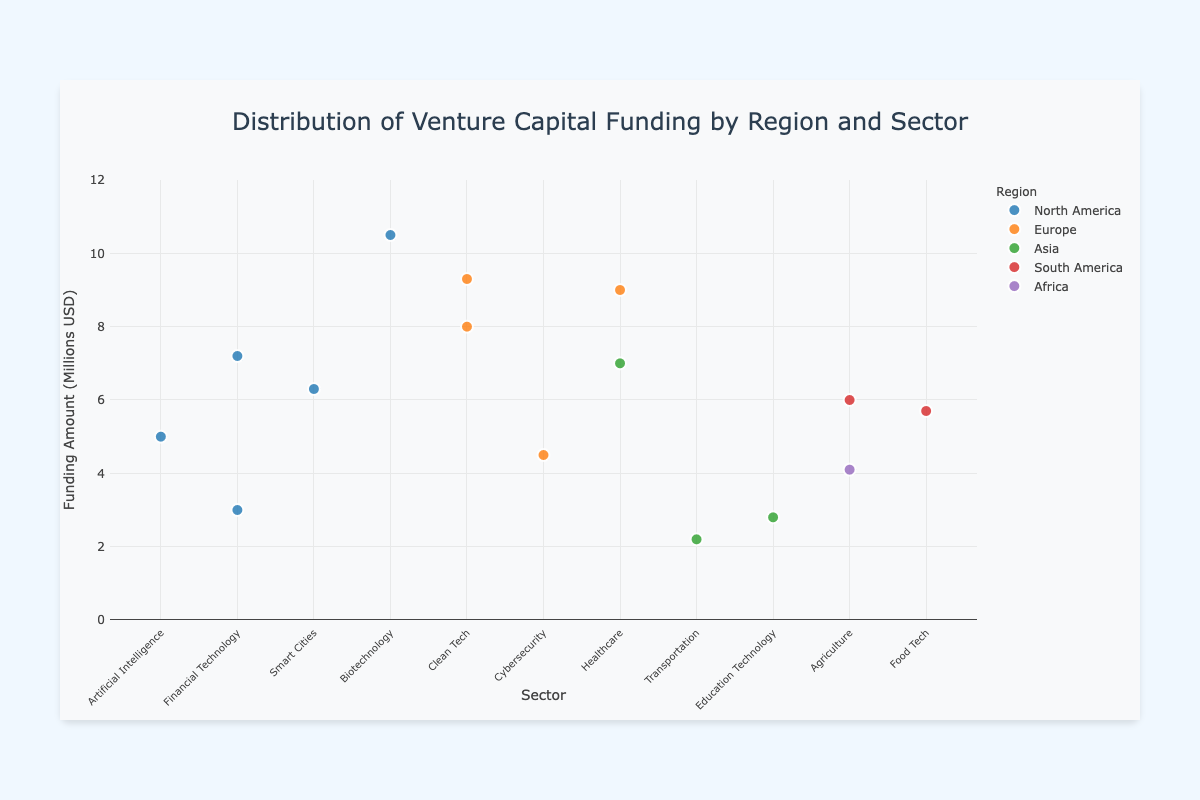What is the title of the figure? The title is located at the top of the figure. It provides information about what the figure represents.
Answer: Distribution of Venture Capital Funding by Region and Sector What region has the startup with the highest funding amount? The region with the startup that has the highest funding amount can be found by examining the points on the chart and identifying the highest y-value.
Answer: North America How many startups are in the Healthcare sector in the entire dataset? To determine the number of startups in the Healthcare sector, count the number of markers labeled as Healthcare in the x-axis.
Answer: 2 Which region has the most diverse number of sectors represented? To answer this, count the number of different sectors for each region in the figure and compare.
Answer: Europe What is the average funding amount for startups in North America? Sum the funding amounts for all North American startups and divide by the number of startups. (5 + 3 + 6.3 + 10.5 + 7.2) / 5 = 32 / 5 = 6.4
Answer: 6.4 million USD Is there any sector that appears in all geographic regions? Check each sector on the x-axis and see if there is one that is represented in each of the regions' traces (colors).
Answer: No Which sector received the highest funding in Europe? Look at the markers in the trace for Europe and identify the one with the highest y-value.
Answer: Clean Tech What is the total combined funding amount of startups in the Clean Tech sector? Sum the funding amounts for startups in the Clean Tech sector across all regions (8 + 9.3).
Answer: 17.3 million USD Which region has the startup with the lowest funding amount, and what is the sector? Find the marker with the lowest y-value and note its region and sector.
Answer: Asia, Transportation How does the funding amount for CyberSecure Labs compare with FinTech Affiliates? Identify the funding amounts for CyberSecure Labs and FinTech Affiliates on the chart and compare the y-values.
Answer: CyberSecure Labs has 4.5 million USD, FinTech Affiliates has 3 million USD. CyberSecure Labs received more funding 